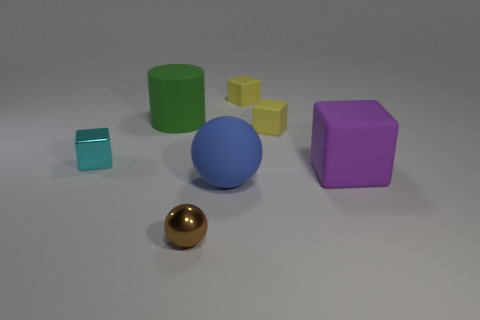How would you describe the lighting and shadows in this image? The lighting in the image appears to be diffused, creating soft shadows which suggest an overcast or filtered light source, typically used in studio photography. There's a light source coming from the upper left as indicated by the shadows being cast towards the lower right. The softness of the shadows suggests that the light source is not extremely close to the objects. 